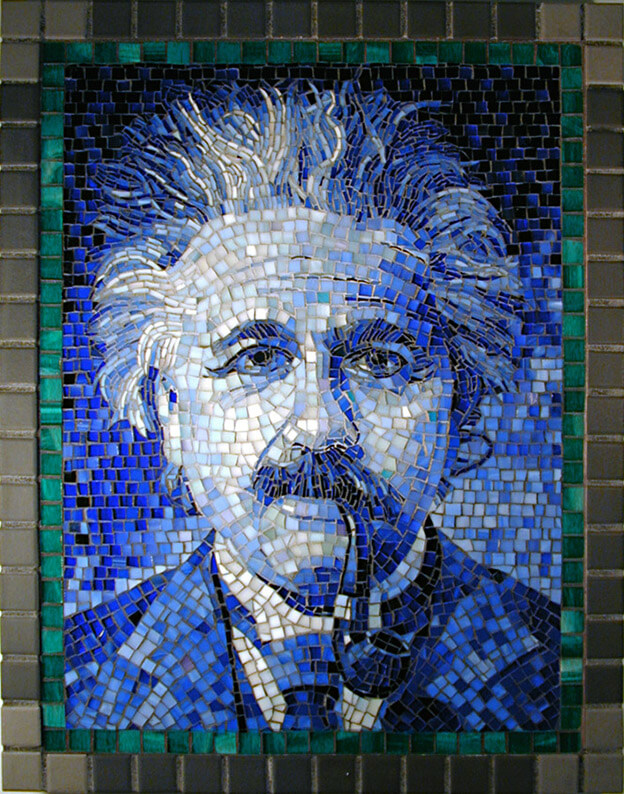Considering the level of detail and the chosen colors for the mosaic, what might have been the artist's intention in choosing this particular color palette for the portrait, and how does it contribute to the overall perception of the figure depicted? The artist's choice of blue as the dominant color for the mosaic could be intended to evoke a sense of calmness, wisdom, and intellectual depth, as blue is often associated with these traits. The darker hues at the top may suggest a vastness or infinity, possibly alluding to the depth of thought or the expansive ideas associated with the figure. The transition to lighter blues and then green could symbolize a grounding in reality or the natural world, suggesting that the figure's thoughts, while profound, are also connected to the tangible and the real. Overall, the color palette and its gradient effect contribute to a perception of the figure as a deep thinker with a balance between lofty ideas and practical reality. 